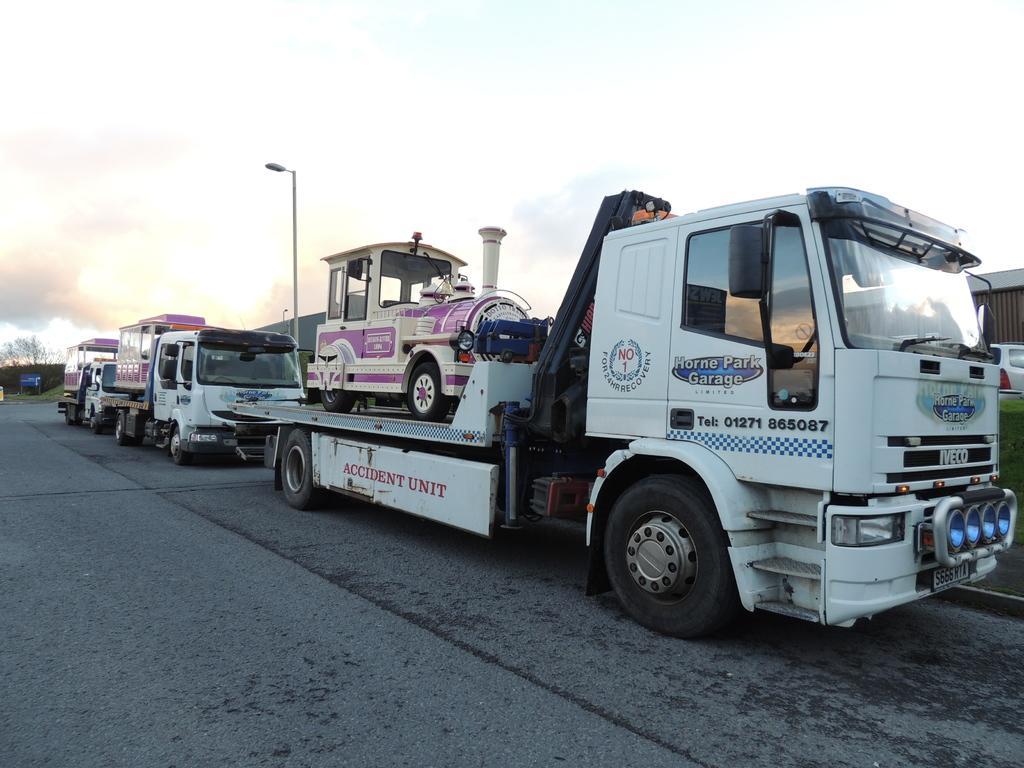Please provide a concise description of this image. In this picture I can see few trucks carrying some vehicles and I can see couple of buildings and a car and I can see trees and a cloudy sky. 